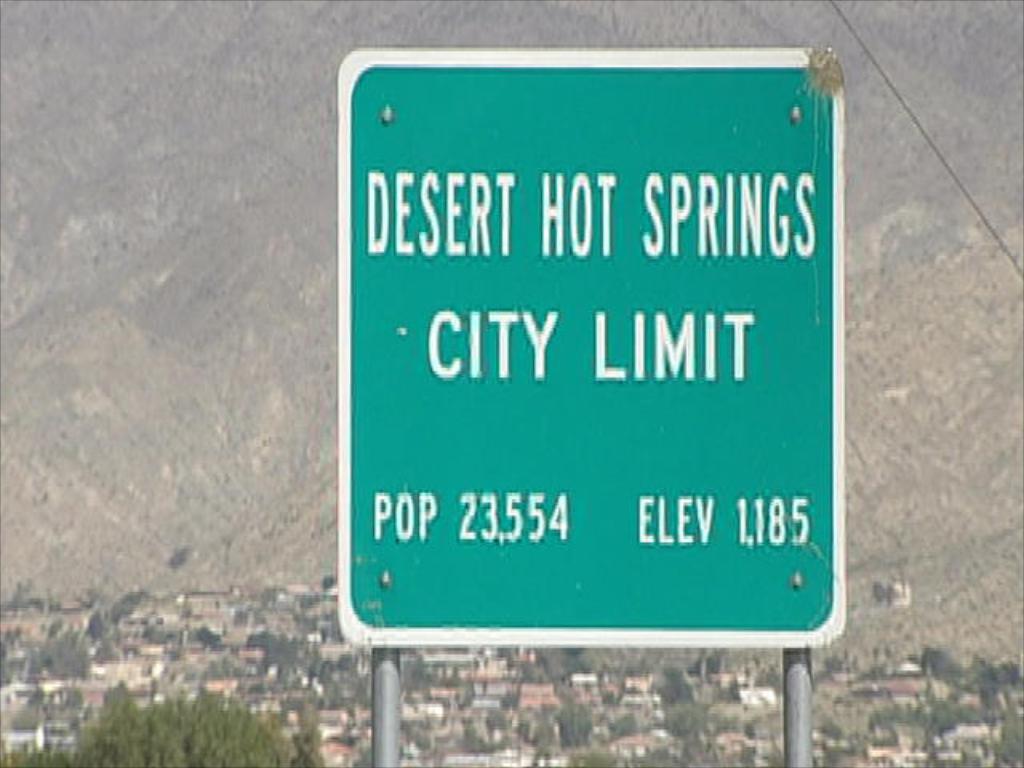The elevation of desert hot springs is?
Provide a short and direct response. 1185. What is the populations of desert hot springs?
Your answer should be compact. 23,554. 